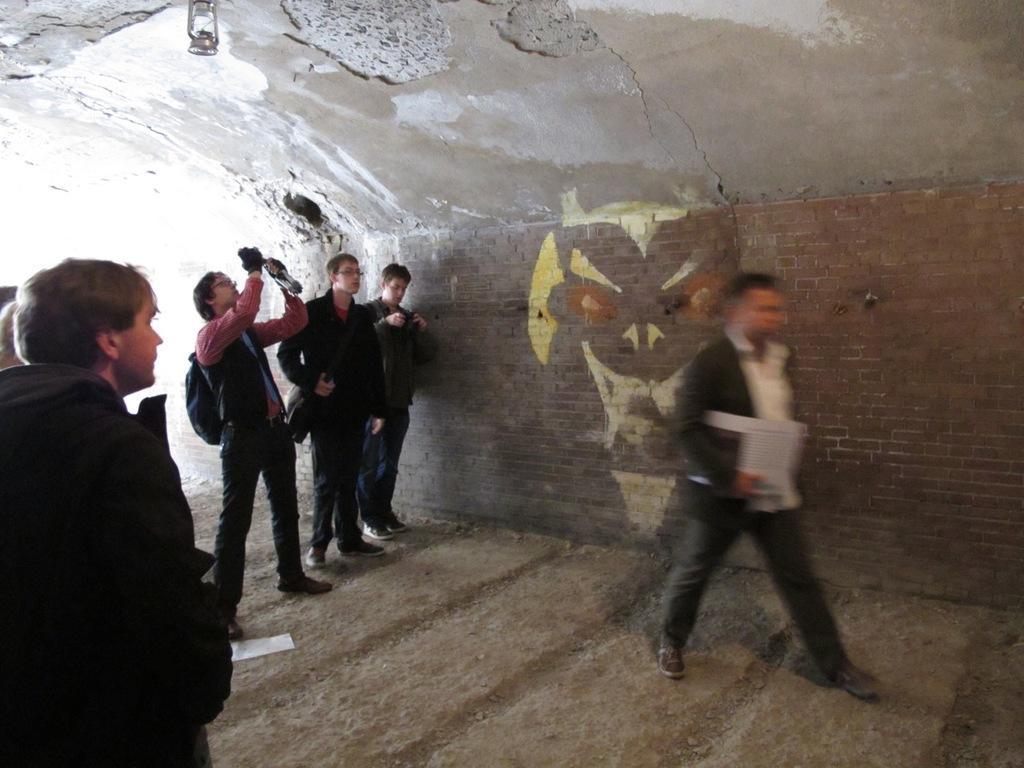Could you give a brief overview of what you see in this image? In this image we can see some persons and other objects. In the background of the image there is a wall with a painting. At the top of the image there is the roof with lamp. At the bottom of the image there is the floor. 